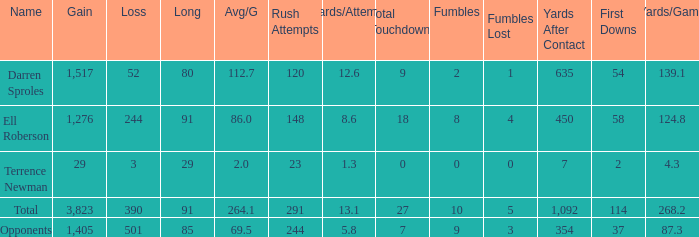When the player gained below 1,405 yards and lost over 390 yards, what's the sum of the long yards? None. 